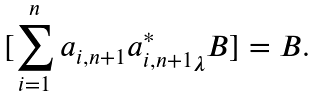<formula> <loc_0><loc_0><loc_500><loc_500>[ \sum _ { i = 1 } ^ { n } a _ { i , n + 1 } { a _ { i , n + 1 } ^ { * } } _ { \boldsymbol \lambda } B ] = B .</formula> 